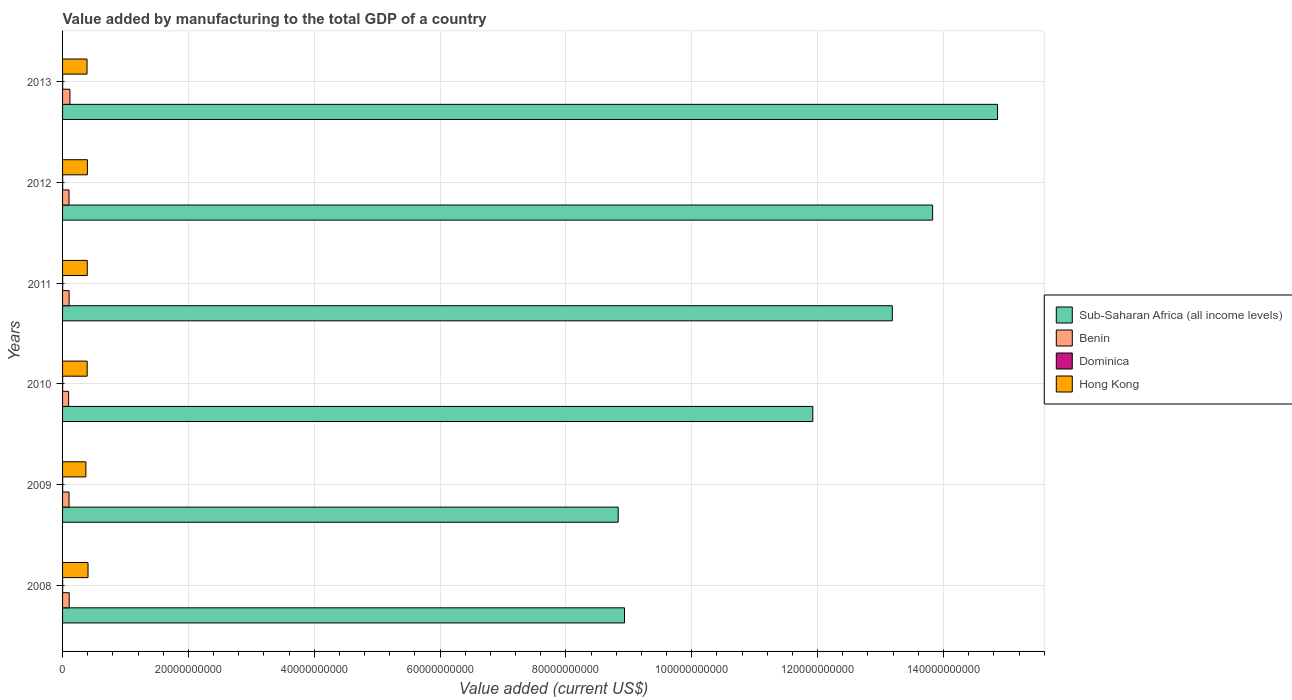How many groups of bars are there?
Your response must be concise. 6. Are the number of bars per tick equal to the number of legend labels?
Provide a short and direct response. Yes. How many bars are there on the 6th tick from the top?
Your response must be concise. 4. In how many cases, is the number of bars for a given year not equal to the number of legend labels?
Offer a very short reply. 0. What is the value added by manufacturing to the total GDP in Dominica in 2013?
Provide a short and direct response. 1.54e+07. Across all years, what is the maximum value added by manufacturing to the total GDP in Dominica?
Keep it short and to the point. 1.54e+07. Across all years, what is the minimum value added by manufacturing to the total GDP in Sub-Saharan Africa (all income levels)?
Ensure brevity in your answer.  8.83e+1. What is the total value added by manufacturing to the total GDP in Dominica in the graph?
Give a very brief answer. 7.75e+07. What is the difference between the value added by manufacturing to the total GDP in Hong Kong in 2011 and that in 2012?
Give a very brief answer. -1.68e+07. What is the difference between the value added by manufacturing to the total GDP in Hong Kong in 2011 and the value added by manufacturing to the total GDP in Sub-Saharan Africa (all income levels) in 2008?
Ensure brevity in your answer.  -8.54e+1. What is the average value added by manufacturing to the total GDP in Sub-Saharan Africa (all income levels) per year?
Offer a terse response. 1.19e+11. In the year 2011, what is the difference between the value added by manufacturing to the total GDP in Hong Kong and value added by manufacturing to the total GDP in Sub-Saharan Africa (all income levels)?
Your answer should be compact. -1.28e+11. In how many years, is the value added by manufacturing to the total GDP in Hong Kong greater than 136000000000 US$?
Provide a succinct answer. 0. What is the ratio of the value added by manufacturing to the total GDP in Benin in 2008 to that in 2013?
Ensure brevity in your answer.  0.9. What is the difference between the highest and the second highest value added by manufacturing to the total GDP in Dominica?
Provide a succinct answer. 4.62e+05. What is the difference between the highest and the lowest value added by manufacturing to the total GDP in Benin?
Offer a very short reply. 2.10e+08. Is the sum of the value added by manufacturing to the total GDP in Benin in 2012 and 2013 greater than the maximum value added by manufacturing to the total GDP in Sub-Saharan Africa (all income levels) across all years?
Give a very brief answer. No. Is it the case that in every year, the sum of the value added by manufacturing to the total GDP in Dominica and value added by manufacturing to the total GDP in Benin is greater than the sum of value added by manufacturing to the total GDP in Sub-Saharan Africa (all income levels) and value added by manufacturing to the total GDP in Hong Kong?
Provide a short and direct response. No. What does the 4th bar from the top in 2010 represents?
Your answer should be compact. Sub-Saharan Africa (all income levels). What does the 3rd bar from the bottom in 2011 represents?
Give a very brief answer. Dominica. How many years are there in the graph?
Keep it short and to the point. 6. Are the values on the major ticks of X-axis written in scientific E-notation?
Offer a terse response. No. Does the graph contain grids?
Give a very brief answer. Yes. Where does the legend appear in the graph?
Your response must be concise. Center right. How are the legend labels stacked?
Give a very brief answer. Vertical. What is the title of the graph?
Your response must be concise. Value added by manufacturing to the total GDP of a country. Does "Mali" appear as one of the legend labels in the graph?
Ensure brevity in your answer.  No. What is the label or title of the X-axis?
Offer a very short reply. Value added (current US$). What is the Value added (current US$) of Sub-Saharan Africa (all income levels) in 2008?
Offer a very short reply. 8.93e+1. What is the Value added (current US$) of Benin in 2008?
Make the answer very short. 1.06e+09. What is the Value added (current US$) of Dominica in 2008?
Offer a terse response. 1.08e+07. What is the Value added (current US$) in Hong Kong in 2008?
Your answer should be compact. 4.05e+09. What is the Value added (current US$) of Sub-Saharan Africa (all income levels) in 2009?
Ensure brevity in your answer.  8.83e+1. What is the Value added (current US$) of Benin in 2009?
Make the answer very short. 1.02e+09. What is the Value added (current US$) in Dominica in 2009?
Make the answer very short. 1.13e+07. What is the Value added (current US$) in Hong Kong in 2009?
Provide a short and direct response. 3.70e+09. What is the Value added (current US$) of Sub-Saharan Africa (all income levels) in 2010?
Ensure brevity in your answer.  1.19e+11. What is the Value added (current US$) of Benin in 2010?
Keep it short and to the point. 9.63e+08. What is the Value added (current US$) of Dominica in 2010?
Provide a succinct answer. 1.17e+07. What is the Value added (current US$) in Hong Kong in 2010?
Make the answer very short. 3.91e+09. What is the Value added (current US$) of Sub-Saharan Africa (all income levels) in 2011?
Make the answer very short. 1.32e+11. What is the Value added (current US$) in Benin in 2011?
Offer a terse response. 1.04e+09. What is the Value added (current US$) of Dominica in 2011?
Keep it short and to the point. 1.33e+07. What is the Value added (current US$) in Hong Kong in 2011?
Offer a very short reply. 3.93e+09. What is the Value added (current US$) of Sub-Saharan Africa (all income levels) in 2012?
Offer a very short reply. 1.38e+11. What is the Value added (current US$) in Benin in 2012?
Give a very brief answer. 1.03e+09. What is the Value added (current US$) of Dominica in 2012?
Your answer should be compact. 1.50e+07. What is the Value added (current US$) of Hong Kong in 2012?
Ensure brevity in your answer.  3.95e+09. What is the Value added (current US$) of Sub-Saharan Africa (all income levels) in 2013?
Your answer should be compact. 1.49e+11. What is the Value added (current US$) of Benin in 2013?
Ensure brevity in your answer.  1.17e+09. What is the Value added (current US$) of Dominica in 2013?
Offer a very short reply. 1.54e+07. What is the Value added (current US$) in Hong Kong in 2013?
Ensure brevity in your answer.  3.89e+09. Across all years, what is the maximum Value added (current US$) of Sub-Saharan Africa (all income levels)?
Give a very brief answer. 1.49e+11. Across all years, what is the maximum Value added (current US$) of Benin?
Keep it short and to the point. 1.17e+09. Across all years, what is the maximum Value added (current US$) of Dominica?
Your answer should be very brief. 1.54e+07. Across all years, what is the maximum Value added (current US$) in Hong Kong?
Your answer should be compact. 4.05e+09. Across all years, what is the minimum Value added (current US$) in Sub-Saharan Africa (all income levels)?
Ensure brevity in your answer.  8.83e+1. Across all years, what is the minimum Value added (current US$) of Benin?
Give a very brief answer. 9.63e+08. Across all years, what is the minimum Value added (current US$) of Dominica?
Make the answer very short. 1.08e+07. Across all years, what is the minimum Value added (current US$) in Hong Kong?
Provide a short and direct response. 3.70e+09. What is the total Value added (current US$) of Sub-Saharan Africa (all income levels) in the graph?
Give a very brief answer. 7.16e+11. What is the total Value added (current US$) of Benin in the graph?
Make the answer very short. 6.28e+09. What is the total Value added (current US$) in Dominica in the graph?
Your response must be concise. 7.75e+07. What is the total Value added (current US$) of Hong Kong in the graph?
Keep it short and to the point. 2.34e+1. What is the difference between the Value added (current US$) of Sub-Saharan Africa (all income levels) in 2008 and that in 2009?
Make the answer very short. 1.00e+09. What is the difference between the Value added (current US$) of Benin in 2008 and that in 2009?
Offer a very short reply. 3.15e+07. What is the difference between the Value added (current US$) of Dominica in 2008 and that in 2009?
Provide a succinct answer. -5.48e+05. What is the difference between the Value added (current US$) in Hong Kong in 2008 and that in 2009?
Provide a short and direct response. 3.42e+08. What is the difference between the Value added (current US$) in Sub-Saharan Africa (all income levels) in 2008 and that in 2010?
Your answer should be compact. -2.99e+1. What is the difference between the Value added (current US$) of Benin in 2008 and that in 2010?
Make the answer very short. 9.30e+07. What is the difference between the Value added (current US$) in Dominica in 2008 and that in 2010?
Make the answer very short. -8.69e+05. What is the difference between the Value added (current US$) in Hong Kong in 2008 and that in 2010?
Your response must be concise. 1.32e+08. What is the difference between the Value added (current US$) in Sub-Saharan Africa (all income levels) in 2008 and that in 2011?
Provide a short and direct response. -4.26e+1. What is the difference between the Value added (current US$) in Benin in 2008 and that in 2011?
Your response must be concise. 1.61e+07. What is the difference between the Value added (current US$) in Dominica in 2008 and that in 2011?
Make the answer very short. -2.52e+06. What is the difference between the Value added (current US$) of Hong Kong in 2008 and that in 2011?
Offer a very short reply. 1.18e+08. What is the difference between the Value added (current US$) in Sub-Saharan Africa (all income levels) in 2008 and that in 2012?
Ensure brevity in your answer.  -4.90e+1. What is the difference between the Value added (current US$) in Benin in 2008 and that in 2012?
Provide a short and direct response. 3.10e+07. What is the difference between the Value added (current US$) of Dominica in 2008 and that in 2012?
Your answer should be compact. -4.17e+06. What is the difference between the Value added (current US$) of Hong Kong in 2008 and that in 2012?
Your response must be concise. 1.01e+08. What is the difference between the Value added (current US$) of Sub-Saharan Africa (all income levels) in 2008 and that in 2013?
Provide a short and direct response. -5.93e+1. What is the difference between the Value added (current US$) of Benin in 2008 and that in 2013?
Provide a succinct answer. -1.17e+08. What is the difference between the Value added (current US$) in Dominica in 2008 and that in 2013?
Offer a very short reply. -4.63e+06. What is the difference between the Value added (current US$) in Hong Kong in 2008 and that in 2013?
Your answer should be compact. 1.58e+08. What is the difference between the Value added (current US$) of Sub-Saharan Africa (all income levels) in 2009 and that in 2010?
Ensure brevity in your answer.  -3.09e+1. What is the difference between the Value added (current US$) in Benin in 2009 and that in 2010?
Give a very brief answer. 6.15e+07. What is the difference between the Value added (current US$) in Dominica in 2009 and that in 2010?
Offer a terse response. -3.21e+05. What is the difference between the Value added (current US$) in Hong Kong in 2009 and that in 2010?
Offer a very short reply. -2.10e+08. What is the difference between the Value added (current US$) in Sub-Saharan Africa (all income levels) in 2009 and that in 2011?
Keep it short and to the point. -4.36e+1. What is the difference between the Value added (current US$) of Benin in 2009 and that in 2011?
Make the answer very short. -1.53e+07. What is the difference between the Value added (current US$) in Dominica in 2009 and that in 2011?
Offer a very short reply. -1.97e+06. What is the difference between the Value added (current US$) of Hong Kong in 2009 and that in 2011?
Give a very brief answer. -2.24e+08. What is the difference between the Value added (current US$) in Sub-Saharan Africa (all income levels) in 2009 and that in 2012?
Your answer should be very brief. -5.00e+1. What is the difference between the Value added (current US$) of Benin in 2009 and that in 2012?
Ensure brevity in your answer.  -4.08e+05. What is the difference between the Value added (current US$) in Dominica in 2009 and that in 2012?
Offer a terse response. -3.62e+06. What is the difference between the Value added (current US$) of Hong Kong in 2009 and that in 2012?
Provide a succinct answer. -2.41e+08. What is the difference between the Value added (current US$) in Sub-Saharan Africa (all income levels) in 2009 and that in 2013?
Your response must be concise. -6.03e+1. What is the difference between the Value added (current US$) of Benin in 2009 and that in 2013?
Give a very brief answer. -1.48e+08. What is the difference between the Value added (current US$) of Dominica in 2009 and that in 2013?
Offer a terse response. -4.08e+06. What is the difference between the Value added (current US$) in Hong Kong in 2009 and that in 2013?
Your response must be concise. -1.84e+08. What is the difference between the Value added (current US$) of Sub-Saharan Africa (all income levels) in 2010 and that in 2011?
Provide a short and direct response. -1.26e+1. What is the difference between the Value added (current US$) in Benin in 2010 and that in 2011?
Make the answer very short. -7.68e+07. What is the difference between the Value added (current US$) in Dominica in 2010 and that in 2011?
Your answer should be compact. -1.65e+06. What is the difference between the Value added (current US$) of Hong Kong in 2010 and that in 2011?
Your response must be concise. -1.41e+07. What is the difference between the Value added (current US$) of Sub-Saharan Africa (all income levels) in 2010 and that in 2012?
Offer a terse response. -1.90e+1. What is the difference between the Value added (current US$) of Benin in 2010 and that in 2012?
Your response must be concise. -6.19e+07. What is the difference between the Value added (current US$) of Dominica in 2010 and that in 2012?
Provide a short and direct response. -3.30e+06. What is the difference between the Value added (current US$) of Hong Kong in 2010 and that in 2012?
Give a very brief answer. -3.10e+07. What is the difference between the Value added (current US$) in Sub-Saharan Africa (all income levels) in 2010 and that in 2013?
Make the answer very short. -2.94e+1. What is the difference between the Value added (current US$) of Benin in 2010 and that in 2013?
Ensure brevity in your answer.  -2.10e+08. What is the difference between the Value added (current US$) in Dominica in 2010 and that in 2013?
Offer a terse response. -3.76e+06. What is the difference between the Value added (current US$) of Hong Kong in 2010 and that in 2013?
Offer a terse response. 2.61e+07. What is the difference between the Value added (current US$) of Sub-Saharan Africa (all income levels) in 2011 and that in 2012?
Your response must be concise. -6.41e+09. What is the difference between the Value added (current US$) of Benin in 2011 and that in 2012?
Ensure brevity in your answer.  1.49e+07. What is the difference between the Value added (current US$) of Dominica in 2011 and that in 2012?
Your response must be concise. -1.65e+06. What is the difference between the Value added (current US$) of Hong Kong in 2011 and that in 2012?
Ensure brevity in your answer.  -1.68e+07. What is the difference between the Value added (current US$) of Sub-Saharan Africa (all income levels) in 2011 and that in 2013?
Give a very brief answer. -1.67e+1. What is the difference between the Value added (current US$) in Benin in 2011 and that in 2013?
Offer a very short reply. -1.33e+08. What is the difference between the Value added (current US$) in Dominica in 2011 and that in 2013?
Make the answer very short. -2.11e+06. What is the difference between the Value added (current US$) in Hong Kong in 2011 and that in 2013?
Your answer should be compact. 4.02e+07. What is the difference between the Value added (current US$) of Sub-Saharan Africa (all income levels) in 2012 and that in 2013?
Ensure brevity in your answer.  -1.03e+1. What is the difference between the Value added (current US$) in Benin in 2012 and that in 2013?
Offer a terse response. -1.48e+08. What is the difference between the Value added (current US$) of Dominica in 2012 and that in 2013?
Offer a terse response. -4.62e+05. What is the difference between the Value added (current US$) of Hong Kong in 2012 and that in 2013?
Offer a terse response. 5.70e+07. What is the difference between the Value added (current US$) in Sub-Saharan Africa (all income levels) in 2008 and the Value added (current US$) in Benin in 2009?
Your answer should be compact. 8.83e+1. What is the difference between the Value added (current US$) of Sub-Saharan Africa (all income levels) in 2008 and the Value added (current US$) of Dominica in 2009?
Offer a very short reply. 8.93e+1. What is the difference between the Value added (current US$) in Sub-Saharan Africa (all income levels) in 2008 and the Value added (current US$) in Hong Kong in 2009?
Give a very brief answer. 8.56e+1. What is the difference between the Value added (current US$) of Benin in 2008 and the Value added (current US$) of Dominica in 2009?
Give a very brief answer. 1.04e+09. What is the difference between the Value added (current US$) in Benin in 2008 and the Value added (current US$) in Hong Kong in 2009?
Your answer should be very brief. -2.65e+09. What is the difference between the Value added (current US$) of Dominica in 2008 and the Value added (current US$) of Hong Kong in 2009?
Offer a terse response. -3.69e+09. What is the difference between the Value added (current US$) in Sub-Saharan Africa (all income levels) in 2008 and the Value added (current US$) in Benin in 2010?
Offer a very short reply. 8.83e+1. What is the difference between the Value added (current US$) in Sub-Saharan Africa (all income levels) in 2008 and the Value added (current US$) in Dominica in 2010?
Provide a succinct answer. 8.93e+1. What is the difference between the Value added (current US$) in Sub-Saharan Africa (all income levels) in 2008 and the Value added (current US$) in Hong Kong in 2010?
Your response must be concise. 8.54e+1. What is the difference between the Value added (current US$) of Benin in 2008 and the Value added (current US$) of Dominica in 2010?
Offer a very short reply. 1.04e+09. What is the difference between the Value added (current US$) in Benin in 2008 and the Value added (current US$) in Hong Kong in 2010?
Provide a short and direct response. -2.86e+09. What is the difference between the Value added (current US$) in Dominica in 2008 and the Value added (current US$) in Hong Kong in 2010?
Keep it short and to the point. -3.90e+09. What is the difference between the Value added (current US$) in Sub-Saharan Africa (all income levels) in 2008 and the Value added (current US$) in Benin in 2011?
Your response must be concise. 8.83e+1. What is the difference between the Value added (current US$) in Sub-Saharan Africa (all income levels) in 2008 and the Value added (current US$) in Dominica in 2011?
Ensure brevity in your answer.  8.93e+1. What is the difference between the Value added (current US$) in Sub-Saharan Africa (all income levels) in 2008 and the Value added (current US$) in Hong Kong in 2011?
Offer a very short reply. 8.54e+1. What is the difference between the Value added (current US$) of Benin in 2008 and the Value added (current US$) of Dominica in 2011?
Your answer should be compact. 1.04e+09. What is the difference between the Value added (current US$) of Benin in 2008 and the Value added (current US$) of Hong Kong in 2011?
Provide a short and direct response. -2.87e+09. What is the difference between the Value added (current US$) in Dominica in 2008 and the Value added (current US$) in Hong Kong in 2011?
Your answer should be compact. -3.92e+09. What is the difference between the Value added (current US$) of Sub-Saharan Africa (all income levels) in 2008 and the Value added (current US$) of Benin in 2012?
Your answer should be compact. 8.83e+1. What is the difference between the Value added (current US$) in Sub-Saharan Africa (all income levels) in 2008 and the Value added (current US$) in Dominica in 2012?
Ensure brevity in your answer.  8.93e+1. What is the difference between the Value added (current US$) in Sub-Saharan Africa (all income levels) in 2008 and the Value added (current US$) in Hong Kong in 2012?
Offer a very short reply. 8.54e+1. What is the difference between the Value added (current US$) in Benin in 2008 and the Value added (current US$) in Dominica in 2012?
Offer a very short reply. 1.04e+09. What is the difference between the Value added (current US$) of Benin in 2008 and the Value added (current US$) of Hong Kong in 2012?
Ensure brevity in your answer.  -2.89e+09. What is the difference between the Value added (current US$) in Dominica in 2008 and the Value added (current US$) in Hong Kong in 2012?
Your answer should be very brief. -3.93e+09. What is the difference between the Value added (current US$) in Sub-Saharan Africa (all income levels) in 2008 and the Value added (current US$) in Benin in 2013?
Keep it short and to the point. 8.81e+1. What is the difference between the Value added (current US$) in Sub-Saharan Africa (all income levels) in 2008 and the Value added (current US$) in Dominica in 2013?
Make the answer very short. 8.93e+1. What is the difference between the Value added (current US$) of Sub-Saharan Africa (all income levels) in 2008 and the Value added (current US$) of Hong Kong in 2013?
Give a very brief answer. 8.54e+1. What is the difference between the Value added (current US$) of Benin in 2008 and the Value added (current US$) of Dominica in 2013?
Offer a terse response. 1.04e+09. What is the difference between the Value added (current US$) of Benin in 2008 and the Value added (current US$) of Hong Kong in 2013?
Your answer should be very brief. -2.83e+09. What is the difference between the Value added (current US$) in Dominica in 2008 and the Value added (current US$) in Hong Kong in 2013?
Ensure brevity in your answer.  -3.88e+09. What is the difference between the Value added (current US$) in Sub-Saharan Africa (all income levels) in 2009 and the Value added (current US$) in Benin in 2010?
Your answer should be compact. 8.73e+1. What is the difference between the Value added (current US$) in Sub-Saharan Africa (all income levels) in 2009 and the Value added (current US$) in Dominica in 2010?
Offer a very short reply. 8.83e+1. What is the difference between the Value added (current US$) in Sub-Saharan Africa (all income levels) in 2009 and the Value added (current US$) in Hong Kong in 2010?
Offer a terse response. 8.44e+1. What is the difference between the Value added (current US$) in Benin in 2009 and the Value added (current US$) in Dominica in 2010?
Your response must be concise. 1.01e+09. What is the difference between the Value added (current US$) in Benin in 2009 and the Value added (current US$) in Hong Kong in 2010?
Offer a terse response. -2.89e+09. What is the difference between the Value added (current US$) of Dominica in 2009 and the Value added (current US$) of Hong Kong in 2010?
Provide a short and direct response. -3.90e+09. What is the difference between the Value added (current US$) of Sub-Saharan Africa (all income levels) in 2009 and the Value added (current US$) of Benin in 2011?
Keep it short and to the point. 8.73e+1. What is the difference between the Value added (current US$) of Sub-Saharan Africa (all income levels) in 2009 and the Value added (current US$) of Dominica in 2011?
Your answer should be compact. 8.83e+1. What is the difference between the Value added (current US$) in Sub-Saharan Africa (all income levels) in 2009 and the Value added (current US$) in Hong Kong in 2011?
Offer a terse response. 8.44e+1. What is the difference between the Value added (current US$) of Benin in 2009 and the Value added (current US$) of Dominica in 2011?
Give a very brief answer. 1.01e+09. What is the difference between the Value added (current US$) in Benin in 2009 and the Value added (current US$) in Hong Kong in 2011?
Offer a terse response. -2.90e+09. What is the difference between the Value added (current US$) of Dominica in 2009 and the Value added (current US$) of Hong Kong in 2011?
Offer a terse response. -3.92e+09. What is the difference between the Value added (current US$) of Sub-Saharan Africa (all income levels) in 2009 and the Value added (current US$) of Benin in 2012?
Make the answer very short. 8.73e+1. What is the difference between the Value added (current US$) of Sub-Saharan Africa (all income levels) in 2009 and the Value added (current US$) of Dominica in 2012?
Offer a very short reply. 8.83e+1. What is the difference between the Value added (current US$) of Sub-Saharan Africa (all income levels) in 2009 and the Value added (current US$) of Hong Kong in 2012?
Offer a terse response. 8.44e+1. What is the difference between the Value added (current US$) of Benin in 2009 and the Value added (current US$) of Dominica in 2012?
Your answer should be compact. 1.01e+09. What is the difference between the Value added (current US$) of Benin in 2009 and the Value added (current US$) of Hong Kong in 2012?
Your answer should be compact. -2.92e+09. What is the difference between the Value added (current US$) of Dominica in 2009 and the Value added (current US$) of Hong Kong in 2012?
Your answer should be compact. -3.93e+09. What is the difference between the Value added (current US$) in Sub-Saharan Africa (all income levels) in 2009 and the Value added (current US$) in Benin in 2013?
Give a very brief answer. 8.71e+1. What is the difference between the Value added (current US$) in Sub-Saharan Africa (all income levels) in 2009 and the Value added (current US$) in Dominica in 2013?
Your response must be concise. 8.83e+1. What is the difference between the Value added (current US$) in Sub-Saharan Africa (all income levels) in 2009 and the Value added (current US$) in Hong Kong in 2013?
Offer a terse response. 8.44e+1. What is the difference between the Value added (current US$) in Benin in 2009 and the Value added (current US$) in Dominica in 2013?
Your answer should be very brief. 1.01e+09. What is the difference between the Value added (current US$) in Benin in 2009 and the Value added (current US$) in Hong Kong in 2013?
Ensure brevity in your answer.  -2.86e+09. What is the difference between the Value added (current US$) of Dominica in 2009 and the Value added (current US$) of Hong Kong in 2013?
Make the answer very short. -3.88e+09. What is the difference between the Value added (current US$) of Sub-Saharan Africa (all income levels) in 2010 and the Value added (current US$) of Benin in 2011?
Provide a succinct answer. 1.18e+11. What is the difference between the Value added (current US$) in Sub-Saharan Africa (all income levels) in 2010 and the Value added (current US$) in Dominica in 2011?
Provide a succinct answer. 1.19e+11. What is the difference between the Value added (current US$) of Sub-Saharan Africa (all income levels) in 2010 and the Value added (current US$) of Hong Kong in 2011?
Make the answer very short. 1.15e+11. What is the difference between the Value added (current US$) in Benin in 2010 and the Value added (current US$) in Dominica in 2011?
Provide a succinct answer. 9.50e+08. What is the difference between the Value added (current US$) of Benin in 2010 and the Value added (current US$) of Hong Kong in 2011?
Make the answer very short. -2.97e+09. What is the difference between the Value added (current US$) of Dominica in 2010 and the Value added (current US$) of Hong Kong in 2011?
Offer a very short reply. -3.92e+09. What is the difference between the Value added (current US$) of Sub-Saharan Africa (all income levels) in 2010 and the Value added (current US$) of Benin in 2012?
Your answer should be compact. 1.18e+11. What is the difference between the Value added (current US$) of Sub-Saharan Africa (all income levels) in 2010 and the Value added (current US$) of Dominica in 2012?
Your answer should be very brief. 1.19e+11. What is the difference between the Value added (current US$) in Sub-Saharan Africa (all income levels) in 2010 and the Value added (current US$) in Hong Kong in 2012?
Offer a very short reply. 1.15e+11. What is the difference between the Value added (current US$) in Benin in 2010 and the Value added (current US$) in Dominica in 2012?
Your answer should be compact. 9.48e+08. What is the difference between the Value added (current US$) in Benin in 2010 and the Value added (current US$) in Hong Kong in 2012?
Offer a very short reply. -2.98e+09. What is the difference between the Value added (current US$) of Dominica in 2010 and the Value added (current US$) of Hong Kong in 2012?
Keep it short and to the point. -3.93e+09. What is the difference between the Value added (current US$) in Sub-Saharan Africa (all income levels) in 2010 and the Value added (current US$) in Benin in 2013?
Make the answer very short. 1.18e+11. What is the difference between the Value added (current US$) in Sub-Saharan Africa (all income levels) in 2010 and the Value added (current US$) in Dominica in 2013?
Offer a very short reply. 1.19e+11. What is the difference between the Value added (current US$) of Sub-Saharan Africa (all income levels) in 2010 and the Value added (current US$) of Hong Kong in 2013?
Make the answer very short. 1.15e+11. What is the difference between the Value added (current US$) of Benin in 2010 and the Value added (current US$) of Dominica in 2013?
Offer a terse response. 9.48e+08. What is the difference between the Value added (current US$) of Benin in 2010 and the Value added (current US$) of Hong Kong in 2013?
Offer a terse response. -2.92e+09. What is the difference between the Value added (current US$) of Dominica in 2010 and the Value added (current US$) of Hong Kong in 2013?
Your answer should be very brief. -3.88e+09. What is the difference between the Value added (current US$) in Sub-Saharan Africa (all income levels) in 2011 and the Value added (current US$) in Benin in 2012?
Provide a short and direct response. 1.31e+11. What is the difference between the Value added (current US$) of Sub-Saharan Africa (all income levels) in 2011 and the Value added (current US$) of Dominica in 2012?
Ensure brevity in your answer.  1.32e+11. What is the difference between the Value added (current US$) in Sub-Saharan Africa (all income levels) in 2011 and the Value added (current US$) in Hong Kong in 2012?
Make the answer very short. 1.28e+11. What is the difference between the Value added (current US$) in Benin in 2011 and the Value added (current US$) in Dominica in 2012?
Give a very brief answer. 1.03e+09. What is the difference between the Value added (current US$) in Benin in 2011 and the Value added (current US$) in Hong Kong in 2012?
Ensure brevity in your answer.  -2.91e+09. What is the difference between the Value added (current US$) of Dominica in 2011 and the Value added (current US$) of Hong Kong in 2012?
Offer a terse response. -3.93e+09. What is the difference between the Value added (current US$) of Sub-Saharan Africa (all income levels) in 2011 and the Value added (current US$) of Benin in 2013?
Your answer should be very brief. 1.31e+11. What is the difference between the Value added (current US$) of Sub-Saharan Africa (all income levels) in 2011 and the Value added (current US$) of Dominica in 2013?
Your answer should be very brief. 1.32e+11. What is the difference between the Value added (current US$) in Sub-Saharan Africa (all income levels) in 2011 and the Value added (current US$) in Hong Kong in 2013?
Your answer should be compact. 1.28e+11. What is the difference between the Value added (current US$) of Benin in 2011 and the Value added (current US$) of Dominica in 2013?
Make the answer very short. 1.02e+09. What is the difference between the Value added (current US$) in Benin in 2011 and the Value added (current US$) in Hong Kong in 2013?
Make the answer very short. -2.85e+09. What is the difference between the Value added (current US$) in Dominica in 2011 and the Value added (current US$) in Hong Kong in 2013?
Keep it short and to the point. -3.87e+09. What is the difference between the Value added (current US$) of Sub-Saharan Africa (all income levels) in 2012 and the Value added (current US$) of Benin in 2013?
Make the answer very short. 1.37e+11. What is the difference between the Value added (current US$) of Sub-Saharan Africa (all income levels) in 2012 and the Value added (current US$) of Dominica in 2013?
Offer a terse response. 1.38e+11. What is the difference between the Value added (current US$) in Sub-Saharan Africa (all income levels) in 2012 and the Value added (current US$) in Hong Kong in 2013?
Offer a terse response. 1.34e+11. What is the difference between the Value added (current US$) of Benin in 2012 and the Value added (current US$) of Dominica in 2013?
Make the answer very short. 1.01e+09. What is the difference between the Value added (current US$) of Benin in 2012 and the Value added (current US$) of Hong Kong in 2013?
Your answer should be compact. -2.86e+09. What is the difference between the Value added (current US$) in Dominica in 2012 and the Value added (current US$) in Hong Kong in 2013?
Make the answer very short. -3.87e+09. What is the average Value added (current US$) of Sub-Saharan Africa (all income levels) per year?
Provide a succinct answer. 1.19e+11. What is the average Value added (current US$) of Benin per year?
Your answer should be very brief. 1.05e+09. What is the average Value added (current US$) in Dominica per year?
Keep it short and to the point. 1.29e+07. What is the average Value added (current US$) in Hong Kong per year?
Your answer should be compact. 3.90e+09. In the year 2008, what is the difference between the Value added (current US$) in Sub-Saharan Africa (all income levels) and Value added (current US$) in Benin?
Offer a terse response. 8.82e+1. In the year 2008, what is the difference between the Value added (current US$) of Sub-Saharan Africa (all income levels) and Value added (current US$) of Dominica?
Your response must be concise. 8.93e+1. In the year 2008, what is the difference between the Value added (current US$) of Sub-Saharan Africa (all income levels) and Value added (current US$) of Hong Kong?
Make the answer very short. 8.53e+1. In the year 2008, what is the difference between the Value added (current US$) in Benin and Value added (current US$) in Dominica?
Provide a short and direct response. 1.05e+09. In the year 2008, what is the difference between the Value added (current US$) in Benin and Value added (current US$) in Hong Kong?
Give a very brief answer. -2.99e+09. In the year 2008, what is the difference between the Value added (current US$) in Dominica and Value added (current US$) in Hong Kong?
Give a very brief answer. -4.04e+09. In the year 2009, what is the difference between the Value added (current US$) in Sub-Saharan Africa (all income levels) and Value added (current US$) in Benin?
Keep it short and to the point. 8.73e+1. In the year 2009, what is the difference between the Value added (current US$) of Sub-Saharan Africa (all income levels) and Value added (current US$) of Dominica?
Ensure brevity in your answer.  8.83e+1. In the year 2009, what is the difference between the Value added (current US$) of Sub-Saharan Africa (all income levels) and Value added (current US$) of Hong Kong?
Your answer should be compact. 8.46e+1. In the year 2009, what is the difference between the Value added (current US$) of Benin and Value added (current US$) of Dominica?
Make the answer very short. 1.01e+09. In the year 2009, what is the difference between the Value added (current US$) of Benin and Value added (current US$) of Hong Kong?
Your answer should be very brief. -2.68e+09. In the year 2009, what is the difference between the Value added (current US$) of Dominica and Value added (current US$) of Hong Kong?
Ensure brevity in your answer.  -3.69e+09. In the year 2010, what is the difference between the Value added (current US$) in Sub-Saharan Africa (all income levels) and Value added (current US$) in Benin?
Provide a succinct answer. 1.18e+11. In the year 2010, what is the difference between the Value added (current US$) in Sub-Saharan Africa (all income levels) and Value added (current US$) in Dominica?
Your answer should be compact. 1.19e+11. In the year 2010, what is the difference between the Value added (current US$) in Sub-Saharan Africa (all income levels) and Value added (current US$) in Hong Kong?
Your answer should be compact. 1.15e+11. In the year 2010, what is the difference between the Value added (current US$) in Benin and Value added (current US$) in Dominica?
Offer a terse response. 9.52e+08. In the year 2010, what is the difference between the Value added (current US$) in Benin and Value added (current US$) in Hong Kong?
Ensure brevity in your answer.  -2.95e+09. In the year 2010, what is the difference between the Value added (current US$) in Dominica and Value added (current US$) in Hong Kong?
Ensure brevity in your answer.  -3.90e+09. In the year 2011, what is the difference between the Value added (current US$) in Sub-Saharan Africa (all income levels) and Value added (current US$) in Benin?
Ensure brevity in your answer.  1.31e+11. In the year 2011, what is the difference between the Value added (current US$) in Sub-Saharan Africa (all income levels) and Value added (current US$) in Dominica?
Your response must be concise. 1.32e+11. In the year 2011, what is the difference between the Value added (current US$) in Sub-Saharan Africa (all income levels) and Value added (current US$) in Hong Kong?
Your answer should be compact. 1.28e+11. In the year 2011, what is the difference between the Value added (current US$) of Benin and Value added (current US$) of Dominica?
Your answer should be very brief. 1.03e+09. In the year 2011, what is the difference between the Value added (current US$) in Benin and Value added (current US$) in Hong Kong?
Keep it short and to the point. -2.89e+09. In the year 2011, what is the difference between the Value added (current US$) in Dominica and Value added (current US$) in Hong Kong?
Your answer should be very brief. -3.92e+09. In the year 2012, what is the difference between the Value added (current US$) of Sub-Saharan Africa (all income levels) and Value added (current US$) of Benin?
Your answer should be very brief. 1.37e+11. In the year 2012, what is the difference between the Value added (current US$) in Sub-Saharan Africa (all income levels) and Value added (current US$) in Dominica?
Your answer should be very brief. 1.38e+11. In the year 2012, what is the difference between the Value added (current US$) in Sub-Saharan Africa (all income levels) and Value added (current US$) in Hong Kong?
Provide a short and direct response. 1.34e+11. In the year 2012, what is the difference between the Value added (current US$) of Benin and Value added (current US$) of Dominica?
Your response must be concise. 1.01e+09. In the year 2012, what is the difference between the Value added (current US$) of Benin and Value added (current US$) of Hong Kong?
Offer a terse response. -2.92e+09. In the year 2012, what is the difference between the Value added (current US$) in Dominica and Value added (current US$) in Hong Kong?
Give a very brief answer. -3.93e+09. In the year 2013, what is the difference between the Value added (current US$) of Sub-Saharan Africa (all income levels) and Value added (current US$) of Benin?
Offer a very short reply. 1.47e+11. In the year 2013, what is the difference between the Value added (current US$) of Sub-Saharan Africa (all income levels) and Value added (current US$) of Dominica?
Your answer should be very brief. 1.49e+11. In the year 2013, what is the difference between the Value added (current US$) of Sub-Saharan Africa (all income levels) and Value added (current US$) of Hong Kong?
Give a very brief answer. 1.45e+11. In the year 2013, what is the difference between the Value added (current US$) in Benin and Value added (current US$) in Dominica?
Provide a succinct answer. 1.16e+09. In the year 2013, what is the difference between the Value added (current US$) in Benin and Value added (current US$) in Hong Kong?
Provide a short and direct response. -2.72e+09. In the year 2013, what is the difference between the Value added (current US$) in Dominica and Value added (current US$) in Hong Kong?
Ensure brevity in your answer.  -3.87e+09. What is the ratio of the Value added (current US$) in Sub-Saharan Africa (all income levels) in 2008 to that in 2009?
Provide a succinct answer. 1.01. What is the ratio of the Value added (current US$) in Benin in 2008 to that in 2009?
Your response must be concise. 1.03. What is the ratio of the Value added (current US$) in Dominica in 2008 to that in 2009?
Keep it short and to the point. 0.95. What is the ratio of the Value added (current US$) in Hong Kong in 2008 to that in 2009?
Ensure brevity in your answer.  1.09. What is the ratio of the Value added (current US$) in Sub-Saharan Africa (all income levels) in 2008 to that in 2010?
Your answer should be very brief. 0.75. What is the ratio of the Value added (current US$) of Benin in 2008 to that in 2010?
Keep it short and to the point. 1.1. What is the ratio of the Value added (current US$) of Dominica in 2008 to that in 2010?
Your answer should be compact. 0.93. What is the ratio of the Value added (current US$) of Hong Kong in 2008 to that in 2010?
Make the answer very short. 1.03. What is the ratio of the Value added (current US$) of Sub-Saharan Africa (all income levels) in 2008 to that in 2011?
Provide a short and direct response. 0.68. What is the ratio of the Value added (current US$) of Benin in 2008 to that in 2011?
Offer a very short reply. 1.02. What is the ratio of the Value added (current US$) in Dominica in 2008 to that in 2011?
Keep it short and to the point. 0.81. What is the ratio of the Value added (current US$) of Sub-Saharan Africa (all income levels) in 2008 to that in 2012?
Your answer should be compact. 0.65. What is the ratio of the Value added (current US$) of Benin in 2008 to that in 2012?
Offer a terse response. 1.03. What is the ratio of the Value added (current US$) of Dominica in 2008 to that in 2012?
Keep it short and to the point. 0.72. What is the ratio of the Value added (current US$) in Hong Kong in 2008 to that in 2012?
Keep it short and to the point. 1.03. What is the ratio of the Value added (current US$) of Sub-Saharan Africa (all income levels) in 2008 to that in 2013?
Offer a terse response. 0.6. What is the ratio of the Value added (current US$) of Benin in 2008 to that in 2013?
Your response must be concise. 0.9. What is the ratio of the Value added (current US$) of Dominica in 2008 to that in 2013?
Provide a short and direct response. 0.7. What is the ratio of the Value added (current US$) of Hong Kong in 2008 to that in 2013?
Offer a very short reply. 1.04. What is the ratio of the Value added (current US$) in Sub-Saharan Africa (all income levels) in 2009 to that in 2010?
Provide a succinct answer. 0.74. What is the ratio of the Value added (current US$) in Benin in 2009 to that in 2010?
Ensure brevity in your answer.  1.06. What is the ratio of the Value added (current US$) of Dominica in 2009 to that in 2010?
Keep it short and to the point. 0.97. What is the ratio of the Value added (current US$) in Hong Kong in 2009 to that in 2010?
Offer a very short reply. 0.95. What is the ratio of the Value added (current US$) of Sub-Saharan Africa (all income levels) in 2009 to that in 2011?
Offer a very short reply. 0.67. What is the ratio of the Value added (current US$) in Benin in 2009 to that in 2011?
Your answer should be compact. 0.99. What is the ratio of the Value added (current US$) of Dominica in 2009 to that in 2011?
Provide a succinct answer. 0.85. What is the ratio of the Value added (current US$) in Hong Kong in 2009 to that in 2011?
Your response must be concise. 0.94. What is the ratio of the Value added (current US$) in Sub-Saharan Africa (all income levels) in 2009 to that in 2012?
Make the answer very short. 0.64. What is the ratio of the Value added (current US$) in Benin in 2009 to that in 2012?
Give a very brief answer. 1. What is the ratio of the Value added (current US$) in Dominica in 2009 to that in 2012?
Offer a terse response. 0.76. What is the ratio of the Value added (current US$) in Hong Kong in 2009 to that in 2012?
Provide a short and direct response. 0.94. What is the ratio of the Value added (current US$) in Sub-Saharan Africa (all income levels) in 2009 to that in 2013?
Your response must be concise. 0.59. What is the ratio of the Value added (current US$) in Benin in 2009 to that in 2013?
Ensure brevity in your answer.  0.87. What is the ratio of the Value added (current US$) in Dominica in 2009 to that in 2013?
Provide a short and direct response. 0.74. What is the ratio of the Value added (current US$) in Hong Kong in 2009 to that in 2013?
Provide a short and direct response. 0.95. What is the ratio of the Value added (current US$) of Sub-Saharan Africa (all income levels) in 2010 to that in 2011?
Make the answer very short. 0.9. What is the ratio of the Value added (current US$) of Benin in 2010 to that in 2011?
Your answer should be compact. 0.93. What is the ratio of the Value added (current US$) of Dominica in 2010 to that in 2011?
Offer a terse response. 0.88. What is the ratio of the Value added (current US$) in Hong Kong in 2010 to that in 2011?
Keep it short and to the point. 1. What is the ratio of the Value added (current US$) in Sub-Saharan Africa (all income levels) in 2010 to that in 2012?
Your response must be concise. 0.86. What is the ratio of the Value added (current US$) in Benin in 2010 to that in 2012?
Give a very brief answer. 0.94. What is the ratio of the Value added (current US$) in Dominica in 2010 to that in 2012?
Your response must be concise. 0.78. What is the ratio of the Value added (current US$) in Hong Kong in 2010 to that in 2012?
Keep it short and to the point. 0.99. What is the ratio of the Value added (current US$) of Sub-Saharan Africa (all income levels) in 2010 to that in 2013?
Make the answer very short. 0.8. What is the ratio of the Value added (current US$) of Benin in 2010 to that in 2013?
Give a very brief answer. 0.82. What is the ratio of the Value added (current US$) in Dominica in 2010 to that in 2013?
Provide a succinct answer. 0.76. What is the ratio of the Value added (current US$) in Hong Kong in 2010 to that in 2013?
Make the answer very short. 1.01. What is the ratio of the Value added (current US$) in Sub-Saharan Africa (all income levels) in 2011 to that in 2012?
Keep it short and to the point. 0.95. What is the ratio of the Value added (current US$) in Benin in 2011 to that in 2012?
Provide a succinct answer. 1.01. What is the ratio of the Value added (current US$) in Dominica in 2011 to that in 2012?
Give a very brief answer. 0.89. What is the ratio of the Value added (current US$) of Sub-Saharan Africa (all income levels) in 2011 to that in 2013?
Ensure brevity in your answer.  0.89. What is the ratio of the Value added (current US$) in Benin in 2011 to that in 2013?
Your answer should be very brief. 0.89. What is the ratio of the Value added (current US$) in Dominica in 2011 to that in 2013?
Make the answer very short. 0.86. What is the ratio of the Value added (current US$) of Hong Kong in 2011 to that in 2013?
Ensure brevity in your answer.  1.01. What is the ratio of the Value added (current US$) in Sub-Saharan Africa (all income levels) in 2012 to that in 2013?
Offer a terse response. 0.93. What is the ratio of the Value added (current US$) of Benin in 2012 to that in 2013?
Provide a short and direct response. 0.87. What is the ratio of the Value added (current US$) of Hong Kong in 2012 to that in 2013?
Offer a very short reply. 1.01. What is the difference between the highest and the second highest Value added (current US$) of Sub-Saharan Africa (all income levels)?
Your answer should be very brief. 1.03e+1. What is the difference between the highest and the second highest Value added (current US$) of Benin?
Ensure brevity in your answer.  1.17e+08. What is the difference between the highest and the second highest Value added (current US$) in Dominica?
Offer a very short reply. 4.62e+05. What is the difference between the highest and the second highest Value added (current US$) of Hong Kong?
Your answer should be very brief. 1.01e+08. What is the difference between the highest and the lowest Value added (current US$) in Sub-Saharan Africa (all income levels)?
Provide a short and direct response. 6.03e+1. What is the difference between the highest and the lowest Value added (current US$) of Benin?
Give a very brief answer. 2.10e+08. What is the difference between the highest and the lowest Value added (current US$) in Dominica?
Ensure brevity in your answer.  4.63e+06. What is the difference between the highest and the lowest Value added (current US$) in Hong Kong?
Offer a very short reply. 3.42e+08. 